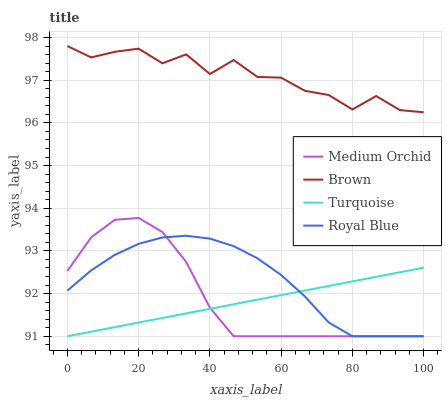Does Turquoise have the minimum area under the curve?
Answer yes or no. Yes. Does Brown have the maximum area under the curve?
Answer yes or no. Yes. Does Medium Orchid have the minimum area under the curve?
Answer yes or no. No. Does Medium Orchid have the maximum area under the curve?
Answer yes or no. No. Is Turquoise the smoothest?
Answer yes or no. Yes. Is Brown the roughest?
Answer yes or no. Yes. Is Medium Orchid the smoothest?
Answer yes or no. No. Is Medium Orchid the roughest?
Answer yes or no. No. Does Brown have the highest value?
Answer yes or no. Yes. Does Medium Orchid have the highest value?
Answer yes or no. No. Is Medium Orchid less than Brown?
Answer yes or no. Yes. Is Brown greater than Turquoise?
Answer yes or no. Yes. Does Royal Blue intersect Turquoise?
Answer yes or no. Yes. Is Royal Blue less than Turquoise?
Answer yes or no. No. Is Royal Blue greater than Turquoise?
Answer yes or no. No. Does Medium Orchid intersect Brown?
Answer yes or no. No. 